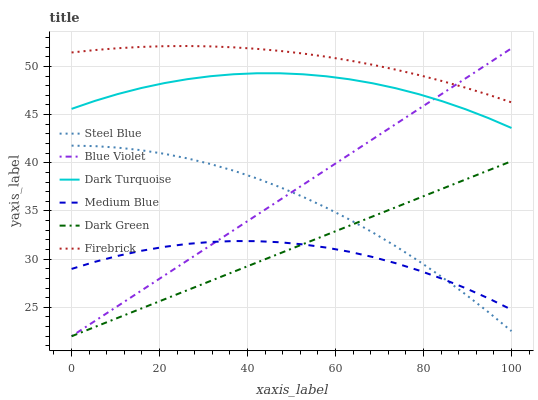Does Medium Blue have the minimum area under the curve?
Answer yes or no. Yes. Does Firebrick have the maximum area under the curve?
Answer yes or no. Yes. Does Firebrick have the minimum area under the curve?
Answer yes or no. No. Does Medium Blue have the maximum area under the curve?
Answer yes or no. No. Is Dark Green the smoothest?
Answer yes or no. Yes. Is Steel Blue the roughest?
Answer yes or no. Yes. Is Firebrick the smoothest?
Answer yes or no. No. Is Firebrick the roughest?
Answer yes or no. No. Does Blue Violet have the lowest value?
Answer yes or no. Yes. Does Medium Blue have the lowest value?
Answer yes or no. No. Does Firebrick have the highest value?
Answer yes or no. Yes. Does Medium Blue have the highest value?
Answer yes or no. No. Is Dark Turquoise less than Firebrick?
Answer yes or no. Yes. Is Dark Turquoise greater than Dark Green?
Answer yes or no. Yes. Does Dark Green intersect Medium Blue?
Answer yes or no. Yes. Is Dark Green less than Medium Blue?
Answer yes or no. No. Is Dark Green greater than Medium Blue?
Answer yes or no. No. Does Dark Turquoise intersect Firebrick?
Answer yes or no. No. 